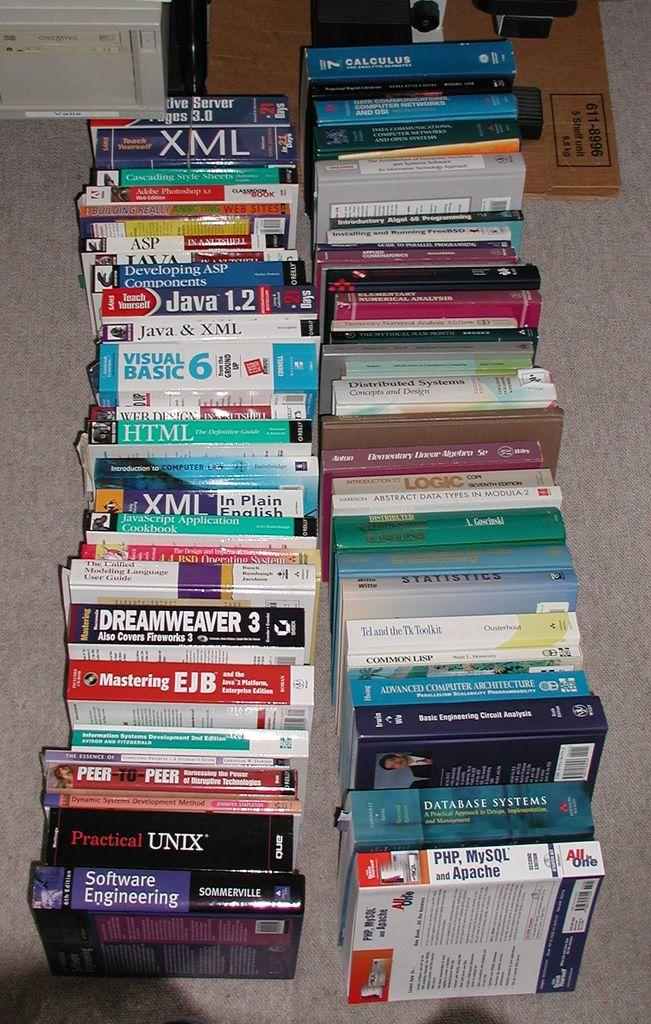<image>
Give a short and clear explanation of the subsequent image. A large collection of books including one on software engineering. 